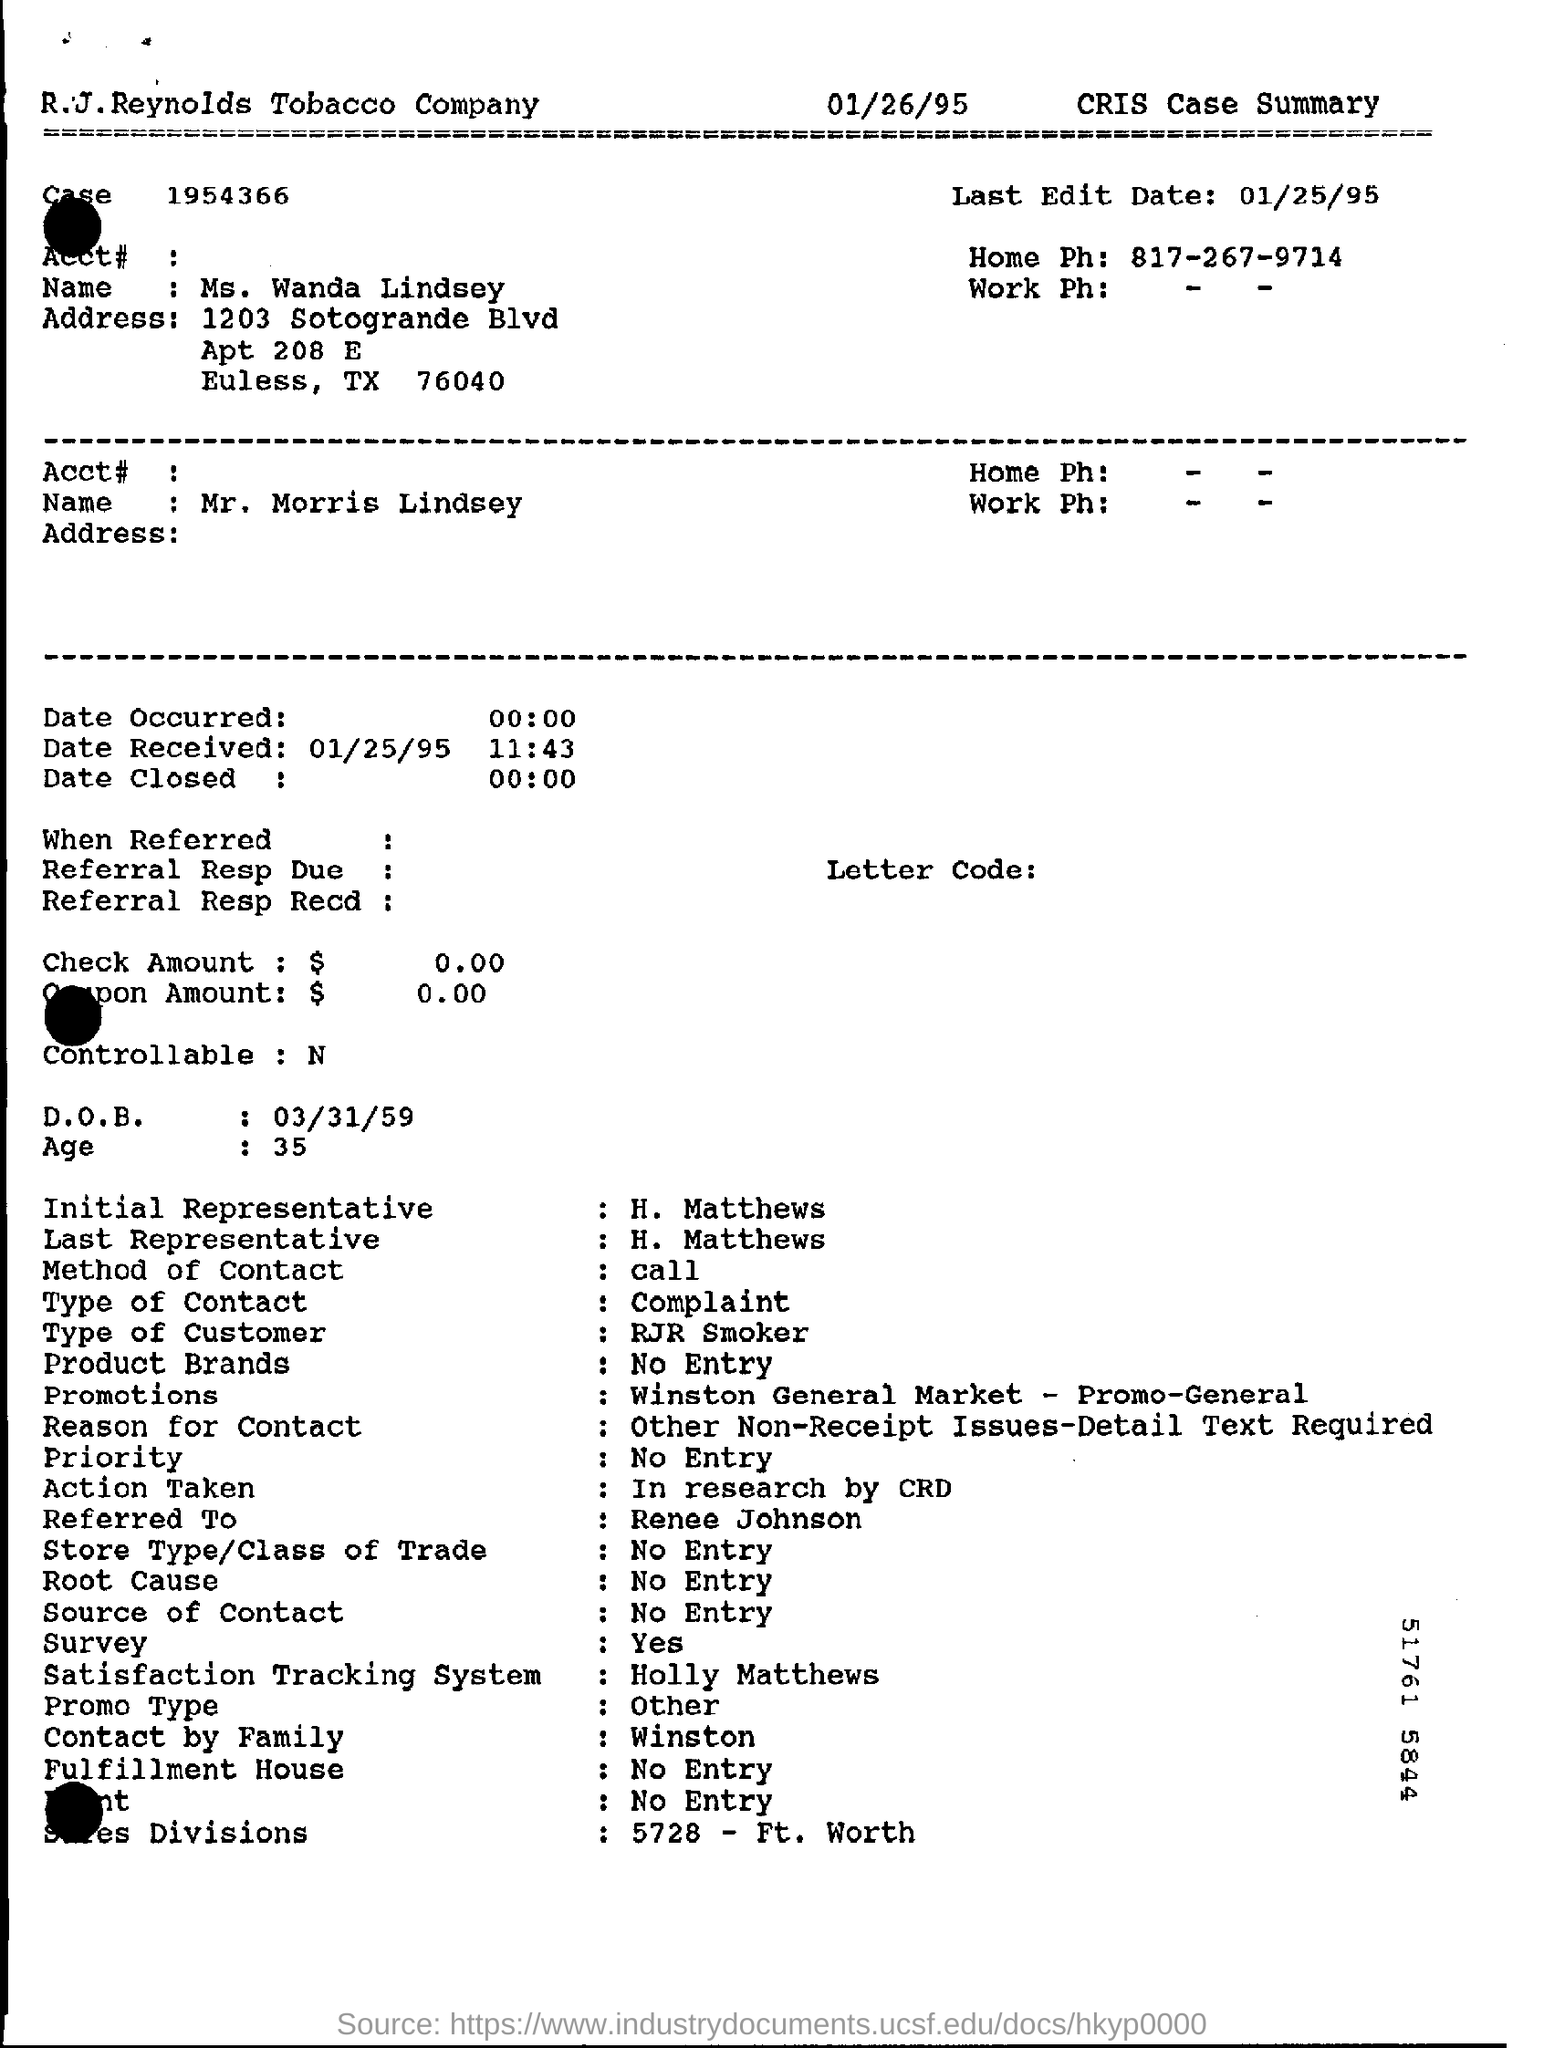What is the case number?
Ensure brevity in your answer.  1954366. What is the last edit?
Keep it short and to the point. 01/25/95. What is the method of contact?
Your answer should be very brief. Call. What is the type of contact?
Provide a short and direct response. Complaint. 